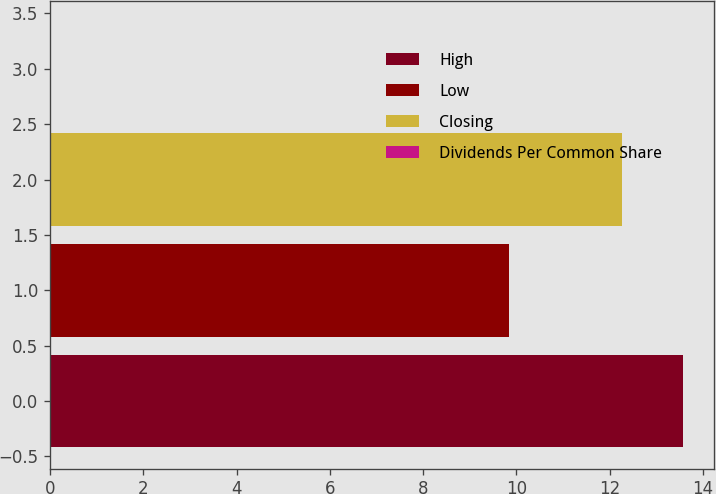Convert chart to OTSL. <chart><loc_0><loc_0><loc_500><loc_500><bar_chart><fcel>High<fcel>Low<fcel>Closing<fcel>Dividends Per Common Share<nl><fcel>13.56<fcel>9.84<fcel>12.26<fcel>0.03<nl></chart> 